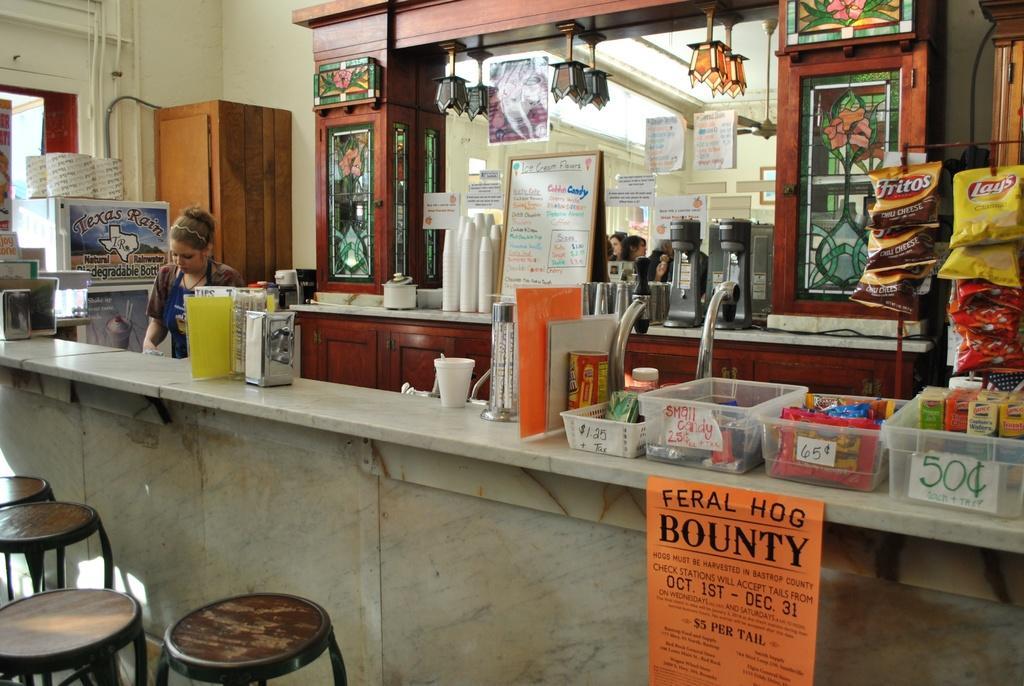Describe this image in one or two sentences. In this picture we can see a woman,here we can see stools,bowls,chips packets,cupboards,some objects and in the background we can see a wall. 